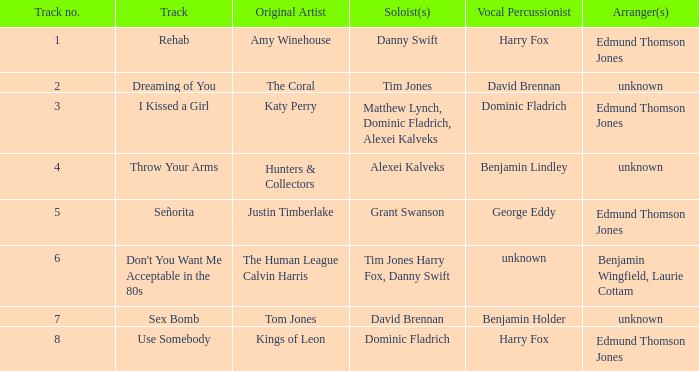Who is the artist where the vocal percussionist is Benjamin Holder? Tom Jones. 